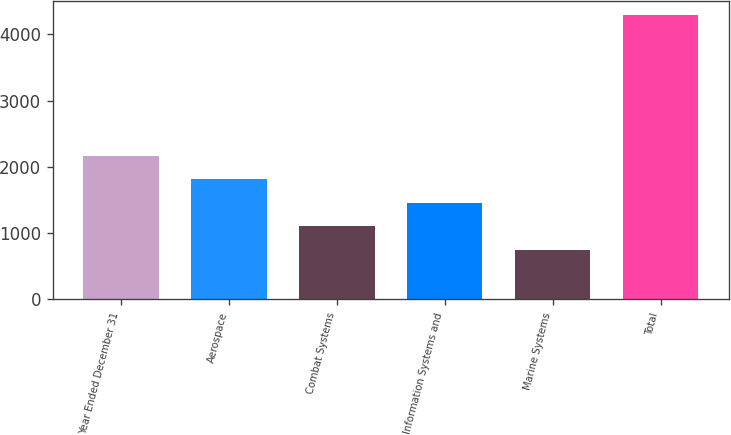Convert chart. <chart><loc_0><loc_0><loc_500><loc_500><bar_chart><fcel>Year Ended December 31<fcel>Aerospace<fcel>Combat Systems<fcel>Information Systems and<fcel>Marine Systems<fcel>Total<nl><fcel>2166.8<fcel>1812.1<fcel>1102.7<fcel>1457.4<fcel>748<fcel>4295<nl></chart> 